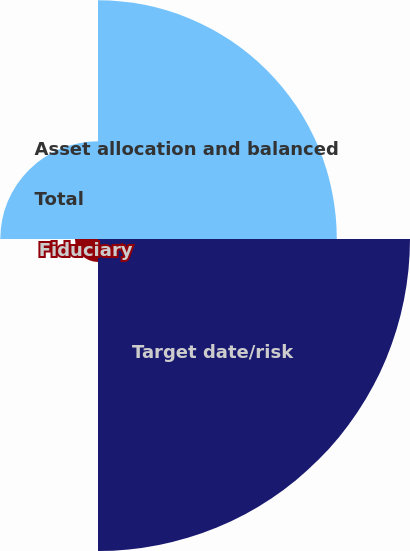Convert chart to OTSL. <chart><loc_0><loc_0><loc_500><loc_500><pie_chart><fcel>Asset allocation and balanced<fcel>Target date/risk<fcel>Fiduciary<fcel>Total<nl><fcel>35.56%<fcel>46.46%<fcel>3.43%<fcel>14.55%<nl></chart> 